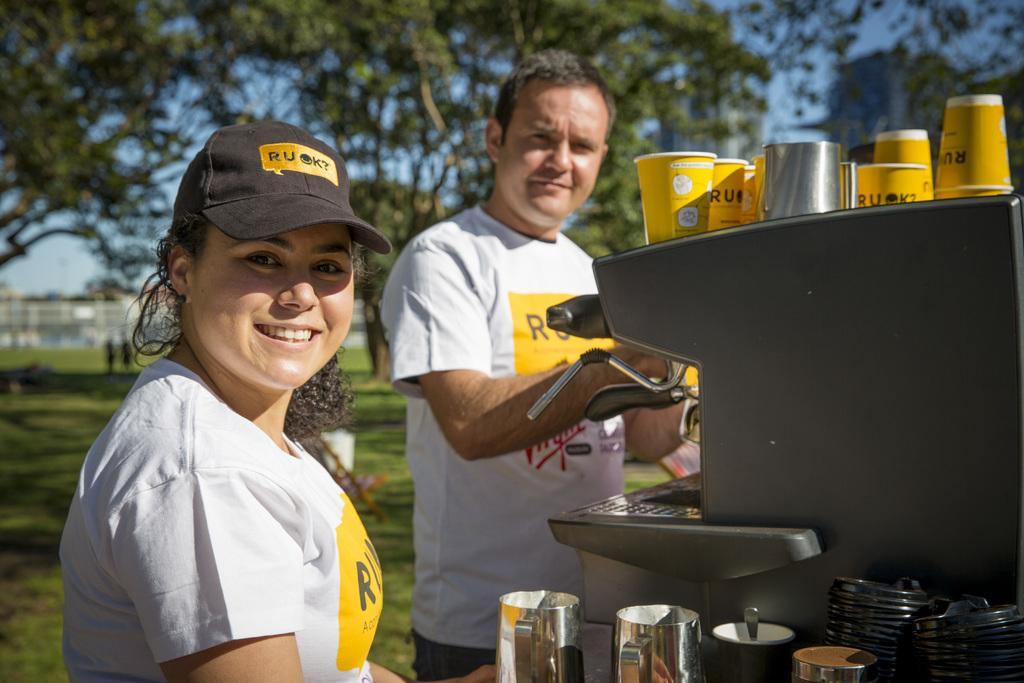Could you give a brief overview of what you see in this image? In this image we can see a man and a woman standing on the ground. To the right side of the image we can see a machine, disposal tumblers and metal mugs. In the background we can see buildings, trees, ground and sky. 